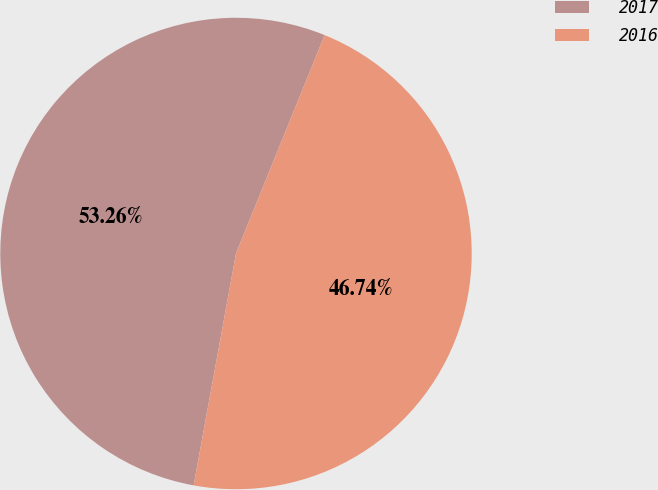Convert chart. <chart><loc_0><loc_0><loc_500><loc_500><pie_chart><fcel>2017<fcel>2016<nl><fcel>53.26%<fcel>46.74%<nl></chart> 